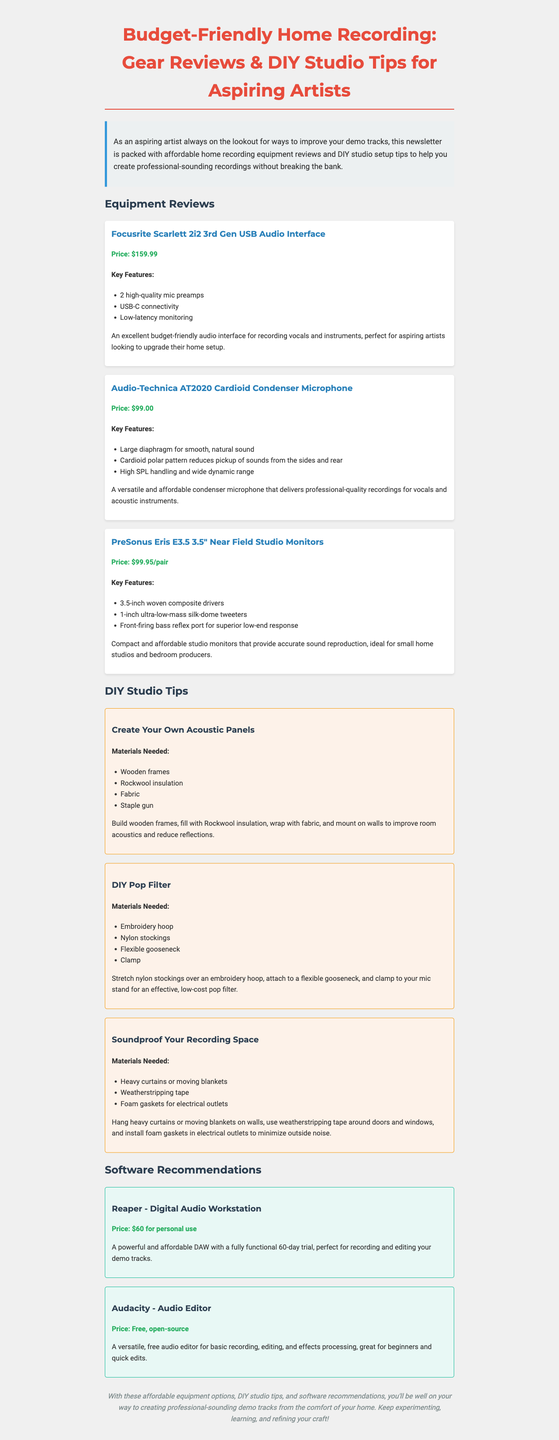what is the price of the Focusrite Scarlett 2i2? The price listed for the Focusrite Scarlett 2i2 is $159.99.
Answer: $159.99 how many key features are listed for the Audio-Technica AT2020? The Audio-Technica AT2020 has three key features listed in the document.
Answer: 3 what is the main material used for creating acoustic panels? The main material needed for creating acoustic panels is Rockwool insulation.
Answer: Rockwool insulation which DIY tip involves using heavy curtains? The DIY tip that involves using heavy curtains is "Soundproof Your Recording Space".
Answer: Soundproof Your Recording Space what is the price of Reaper for personal use? The price of Reaper for personal use is listed as $60.
Answer: $60 which product is described as compact and affordable studio monitors? The product described as compact and affordable studio monitors is the PreSonus Eris E3.5.
Answer: PreSonus Eris E3.5 how many software recommendations are provided in the newsletter? There are two software recommendations provided in the newsletter.
Answer: 2 what type of microphone is the Audio-Technica AT2020? The Audio-Technica AT2020 is a cardioid condenser microphone.
Answer: cardioid condenser microphone 